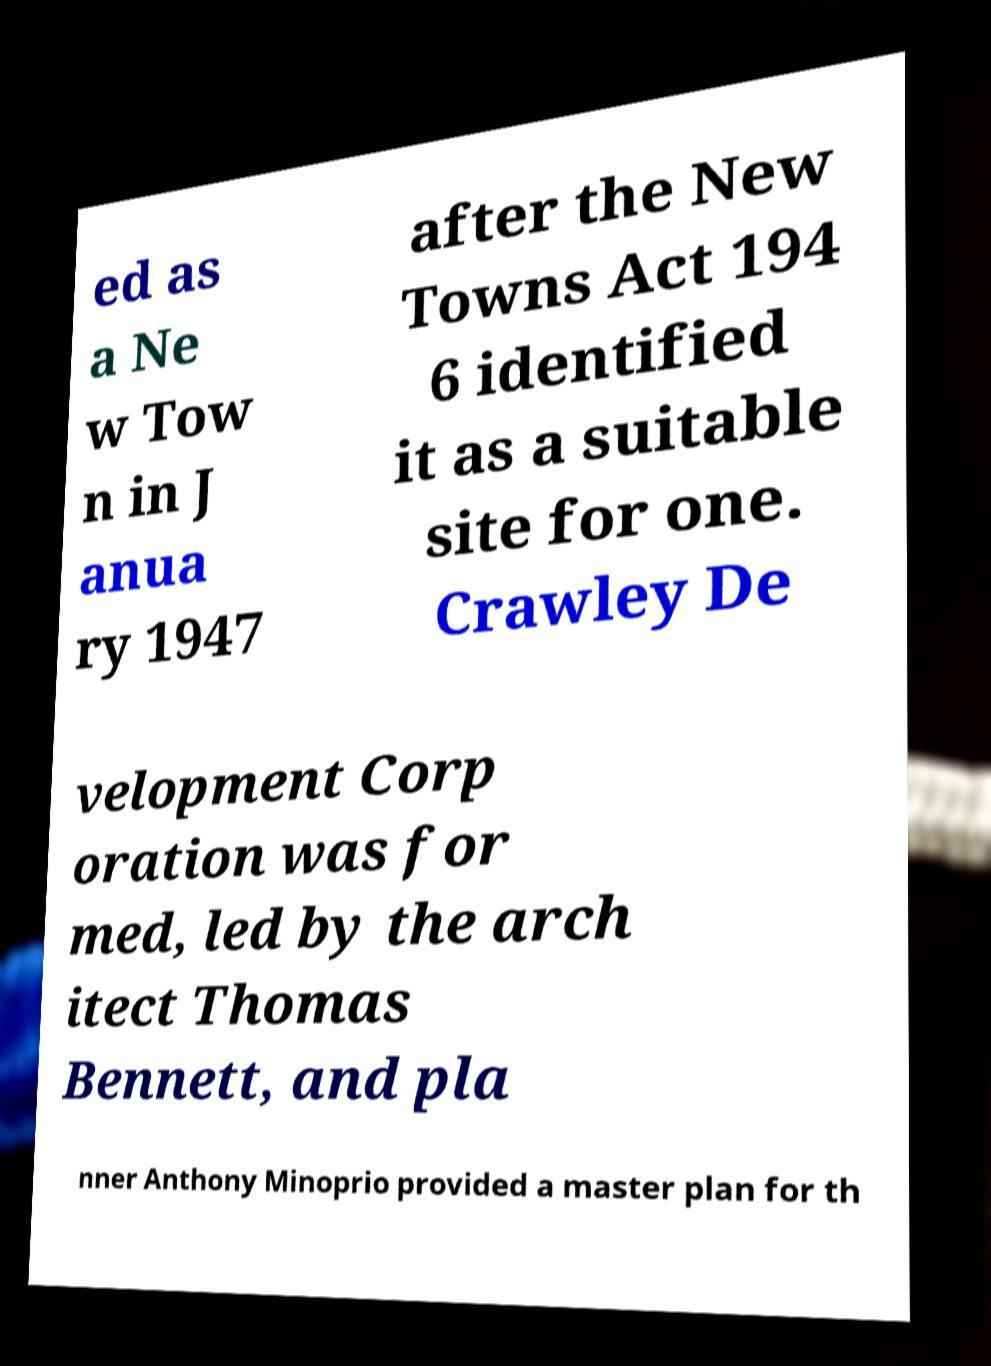What messages or text are displayed in this image? I need them in a readable, typed format. ed as a Ne w Tow n in J anua ry 1947 after the New Towns Act 194 6 identified it as a suitable site for one. Crawley De velopment Corp oration was for med, led by the arch itect Thomas Bennett, and pla nner Anthony Minoprio provided a master plan for th 